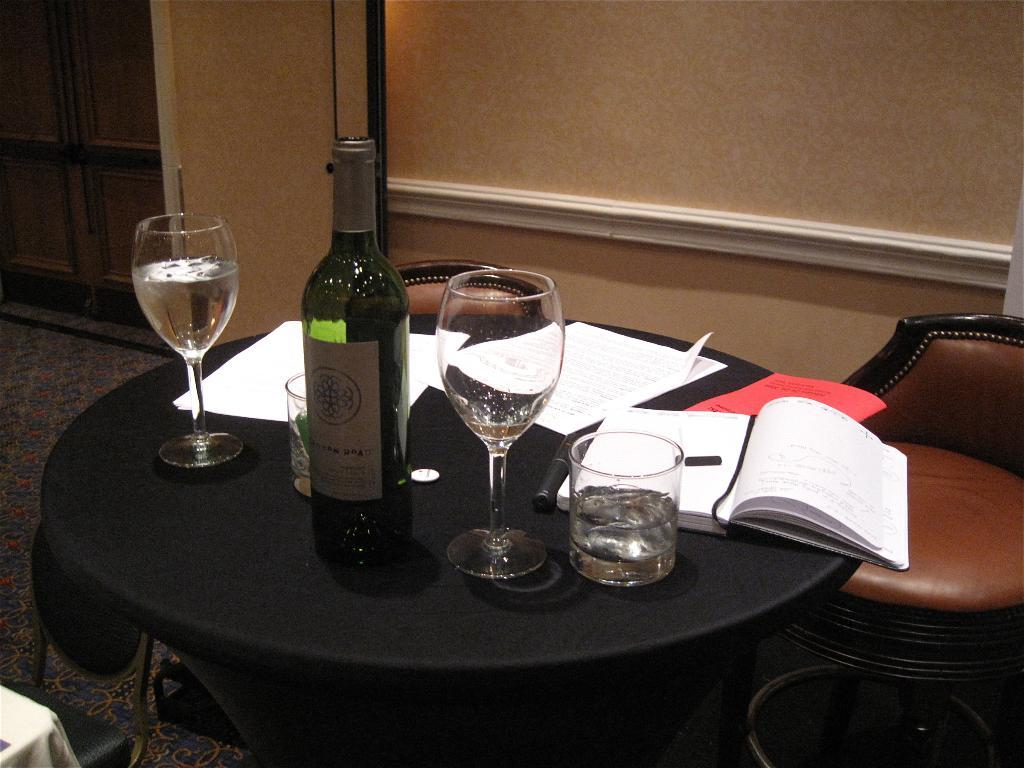What type of furniture is present in the image? There is a table and a chair in the image. What items can be seen on the table? There are glasses, a bottle, and books on the table. What is the background of the image? There is a wall behind the table. What type of industry is depicted in the image? There is no industry depicted in the image; it features a table, chair, and other items on the table. What color is the person's hair in the image? There are no people present in the image, so it is not possible to determine the color of anyone's hair. 